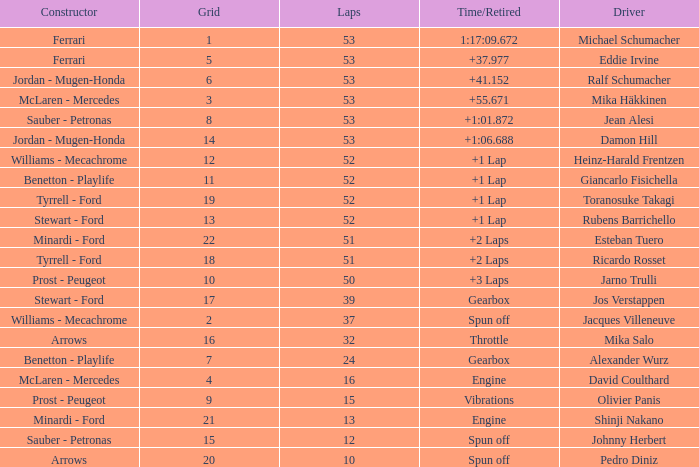What is the grid total for ralf schumacher racing over 53 laps? None. 